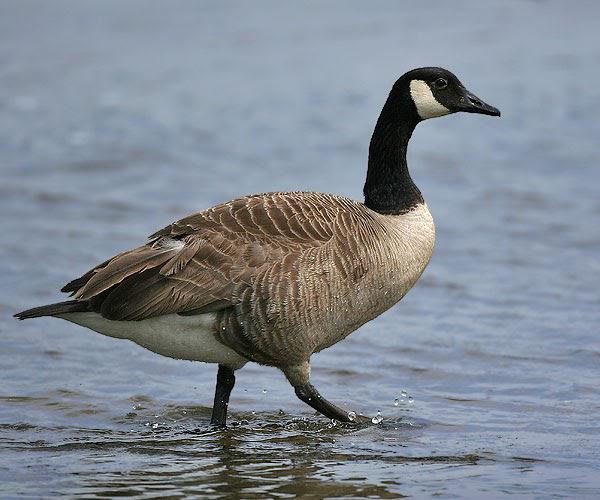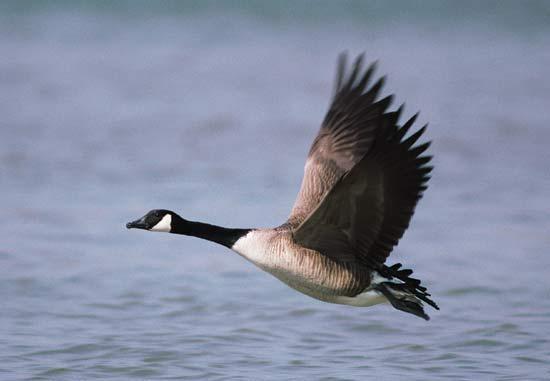The first image is the image on the left, the second image is the image on the right. For the images shown, is this caption "The right image contains more birds than the left image." true? Answer yes or no. No. 